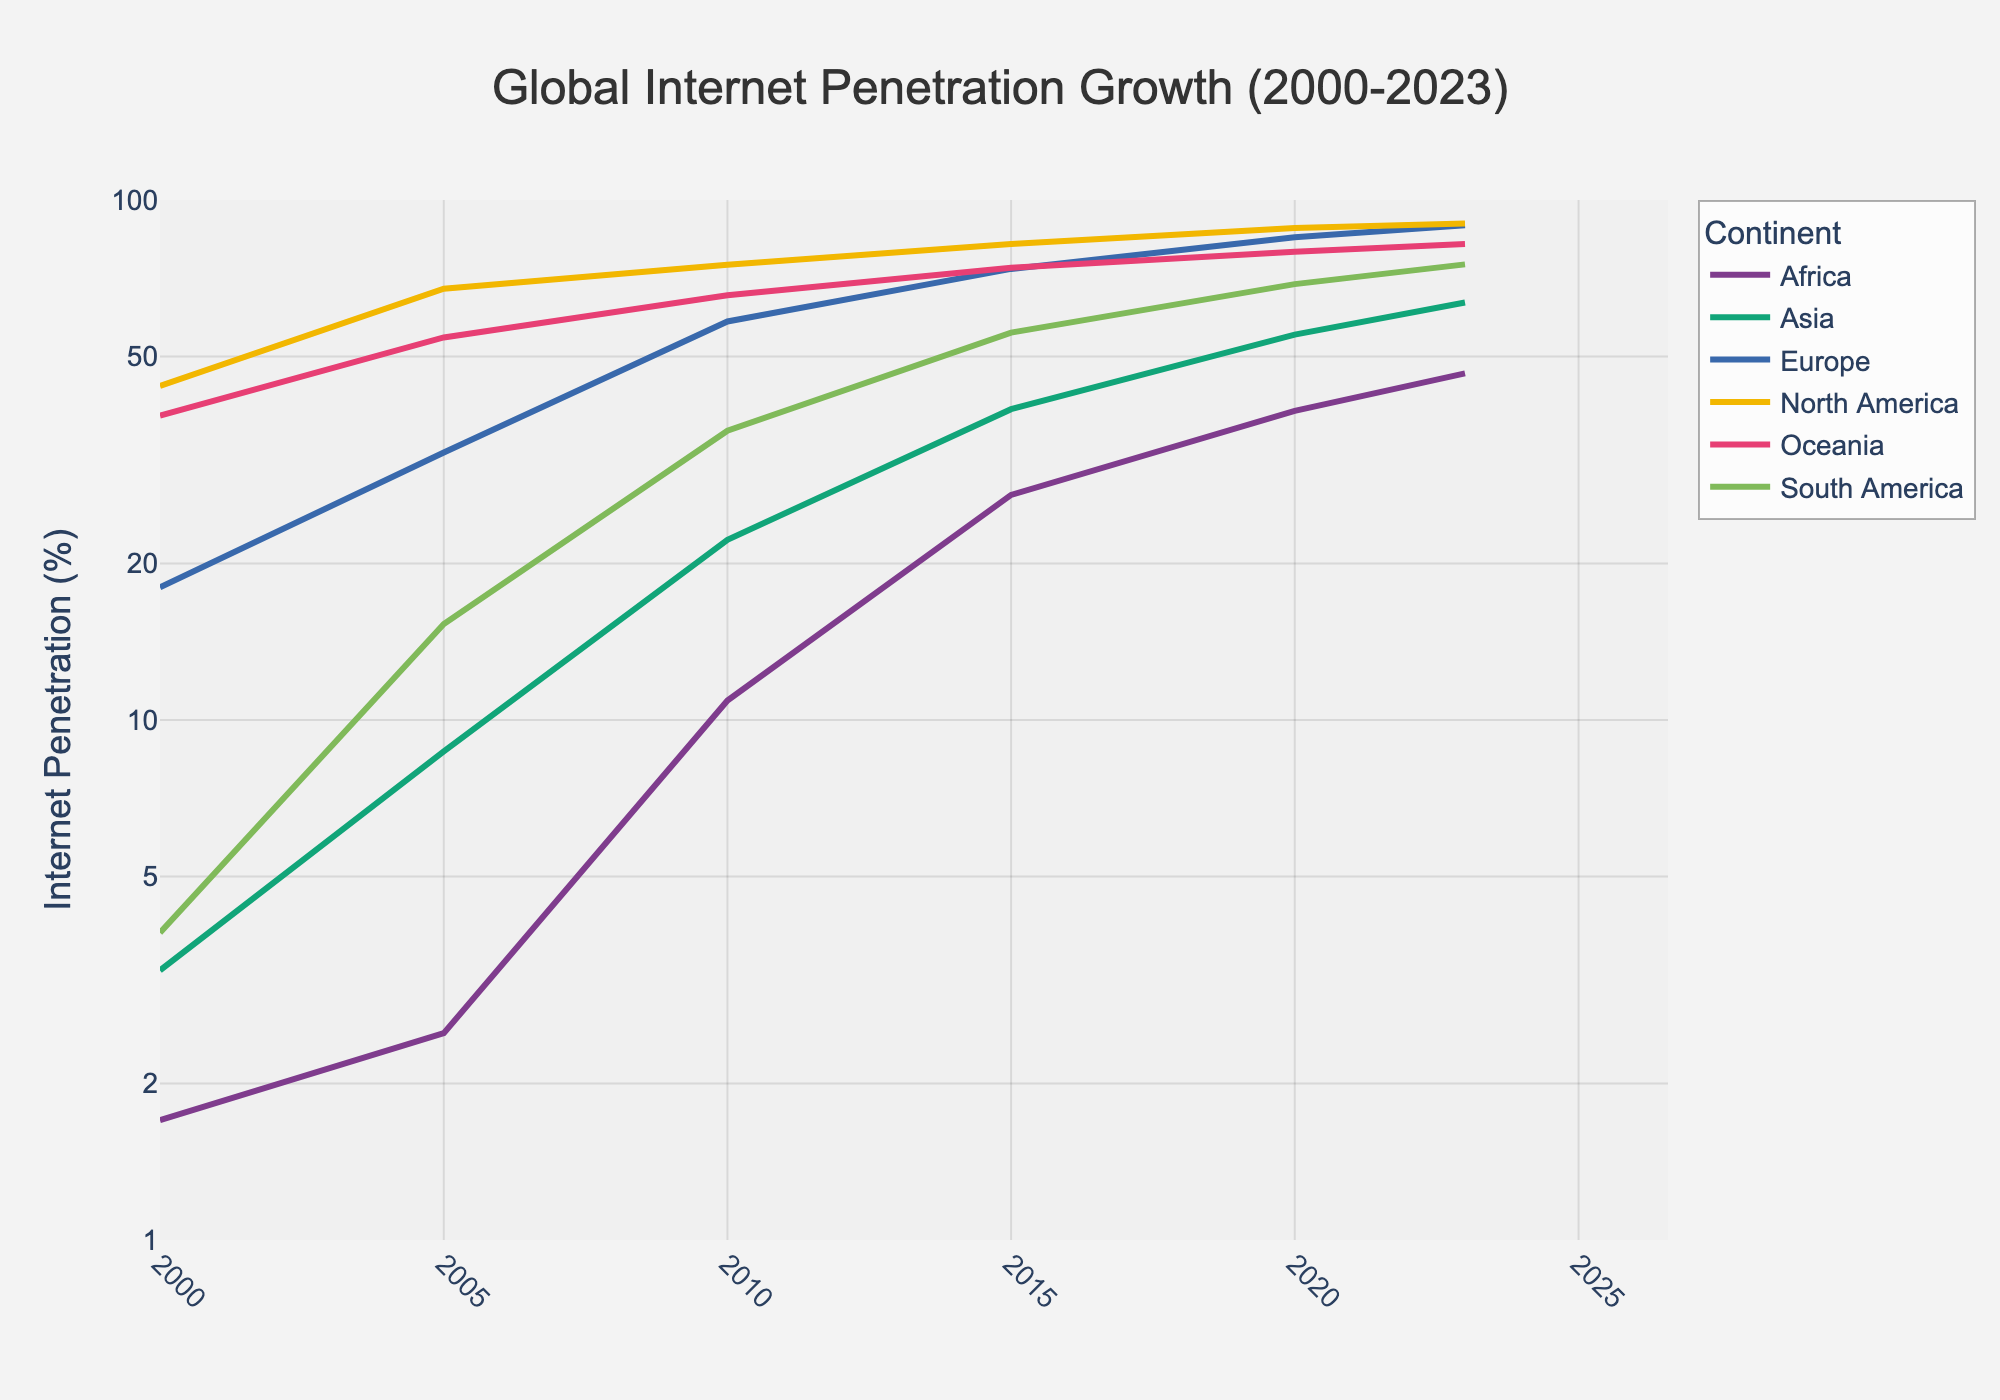Which continent had the highest internet penetration in 2000? The figure shows the internet penetration data across different continents. Looking at the starting point, North America had the highest value marked at 43.9%.
Answer: North America How has Africa's internet penetration changed from 2000 to 2023? Identifying the points marking Africa's data in 2000 and 2023, the internet penetration increased from 1.7% in 2000 to 46.4% in 2023.
Answer: Increased from 1.7% to 46.4% What year did Asia surpass a 50% internet penetration rate? Finding the year on the x-axis where the Asia trace crosses the 50% mark on the y-axis, this happens around 2020.
Answer: 2020 What is the approximate difference in internet penetration between Europe and South America in 2023? Comparing the values for Europe (89.4%) and South America (75.2%) in 2023, the difference is approximately 89.4% - 75.2% = 14.2%.
Answer: 14.2% Which continents had more than 80% internet penetration by 2023? Observing the endpoints of each trace for the year 2023, Europe (89.4%), North America (90.1%), and Oceania (82.3%) all had more than 80% internet penetration.
Answer: Europe, North America, Oceania In 2015, which continent had the lowest internet penetration, and what was the value? Locating the points for 2015 and identifying the lowest value which is for Africa with 27.1%.
Answer: Africa, 27.1% Has any continent's internet penetration growth been linear on the log scale? Analyzing the curve shapes, all continents show exponential growth, indicating that none have a linear progression on the log scale.
Answer: No How many years did it take for Africa's internet penetration to increase from 1.7% to roughly 40%? Looking at the points for Africa, internet penetration reaches about 40% in 2020; thus, it took from 2000 to 2020, totaling 20 years.
Answer: 20 years Which continent showed the most significant growth in the first five years (2000-2005)? Examining the vertical distance from 2000 to 2005 for each continent, Asia had a substantial increase from 3.3% to 8.7%, followed by South America from 3.9% to 15.3%.
Answer: South America 